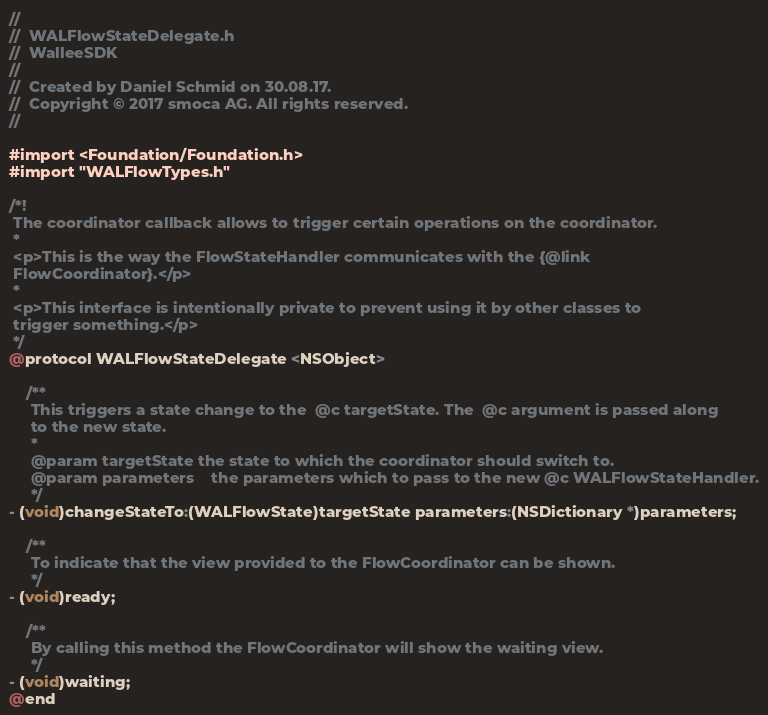Convert code to text. <code><loc_0><loc_0><loc_500><loc_500><_C_>//
//  WALFlowStateDelegate.h
//  WalleeSDK
//
//  Created by Daniel Schmid on 30.08.17.
//  Copyright © 2017 smoca AG. All rights reserved.
//

#import <Foundation/Foundation.h>
#import "WALFlowTypes.h"

/*!
 The coordinator callback allows to trigger certain operations on the coordinator.
 *
 <p>This is the way the FlowStateHandler communicates with the {@link
 FlowCoordinator}.</p>
 *
 <p>This interface is intentionally private to prevent using it by other classes to
 trigger something.</p>
 */
@protocol WALFlowStateDelegate <NSObject>

    /**
     This triggers a state change to the  @c targetState. The  @c argument is passed along
     to the new state.
     *
     @param targetState the state to which the coordinator should switch to.
     @param parameters    the parameters which to pass to the new @c WALFlowStateHandler.
     */
- (void)changeStateTo:(WALFlowState)targetState parameters:(NSDictionary *)parameters;
    
    /**
     To indicate that the view provided to the FlowCoordinator can be shown.
     */
- (void)ready;
    
    /**
     By calling this method the FlowCoordinator will show the waiting view.
     */
- (void)waiting;
@end
</code> 